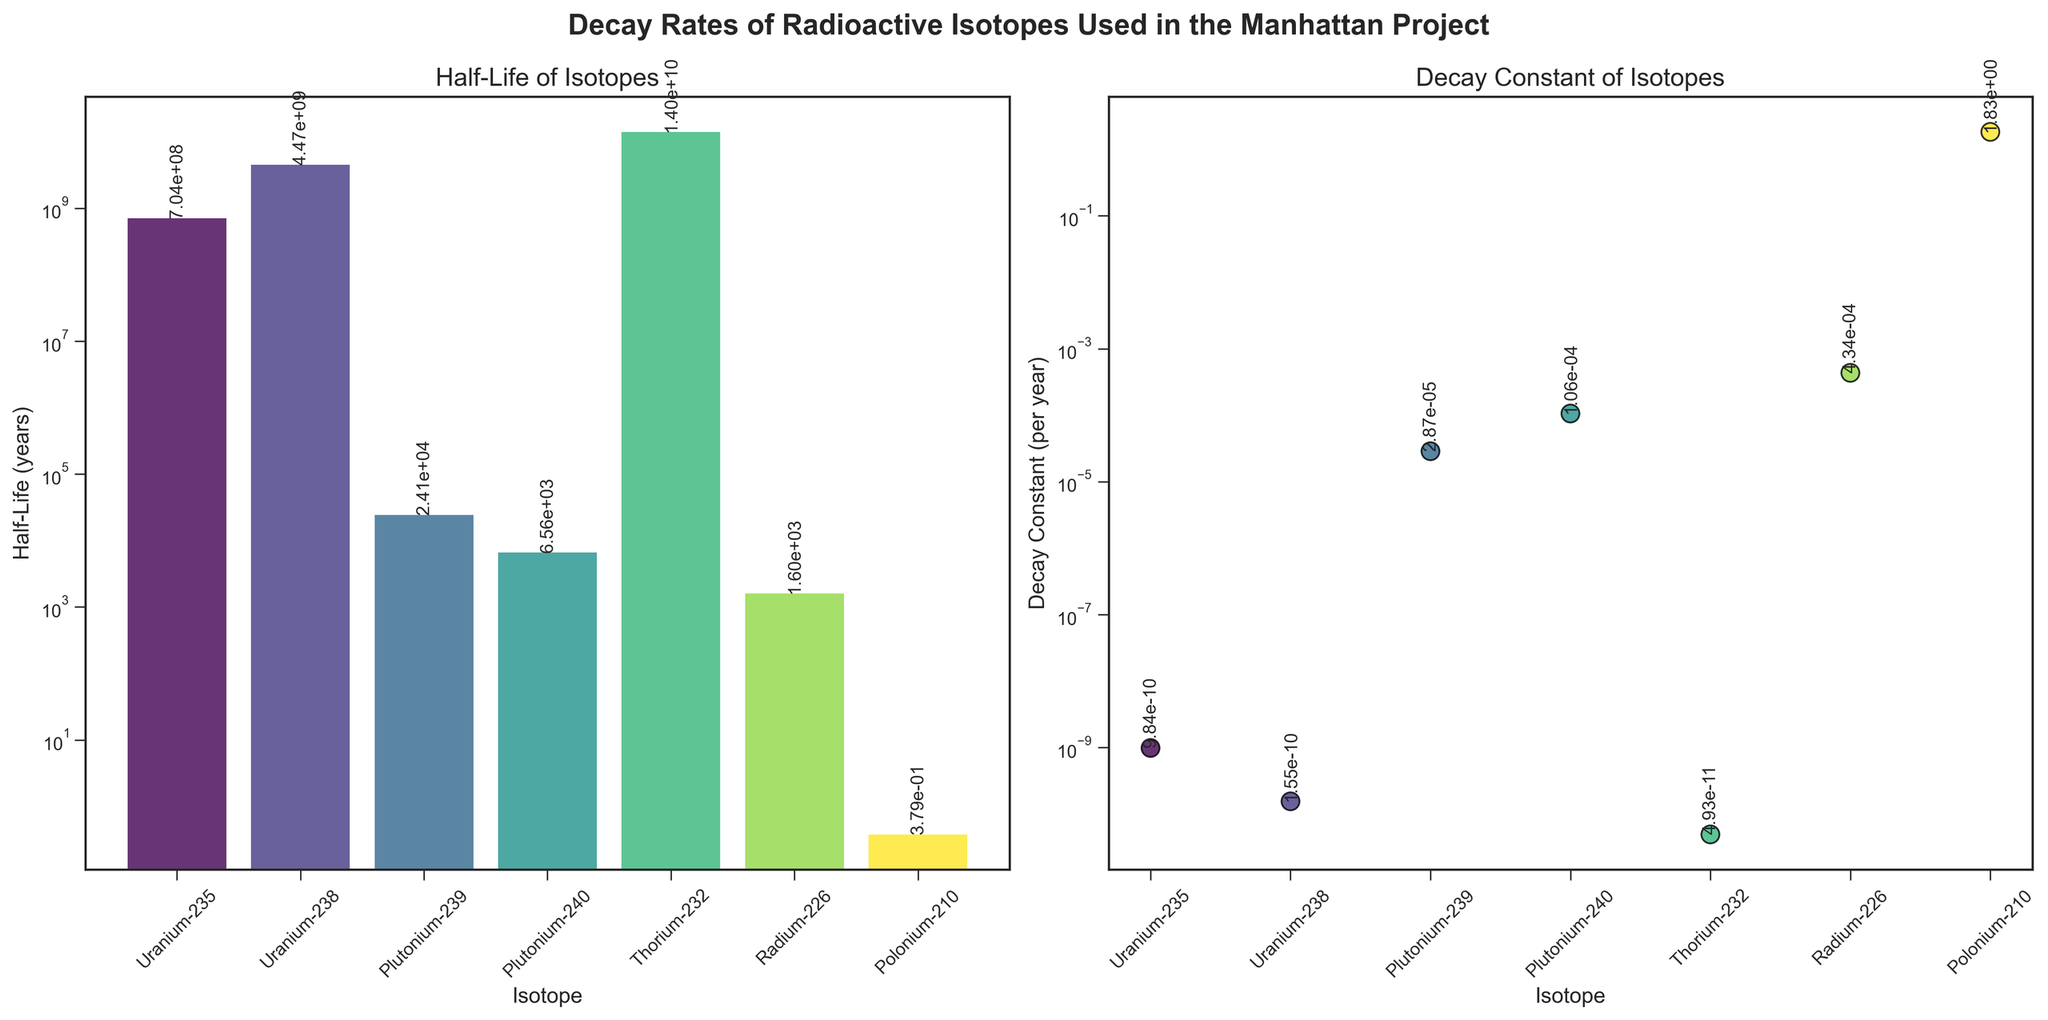What is the half-life of Uranium-235? The half-life can be directly read from the bar height in the subplot for Half-Life of Isotopes. Uranium-235's bar reaches up to approximately 7.04e8 years as labeled.
Answer: 7.04e8 years Which isotope has the highest decay constant? By examining the scatter plot in the subplot for Decay Constant of Isotopes, we see that Polonium-210 has the highest point, with a labeled decay constant of 1.83 per year.
Answer: Polonium-210 How does the half-life of Uranium-238 compare to that of Thorium-232? Find the bars for Uranium-238 and Thorium-232 in the Half-Life subplot. The half-life of Uranium-238 (4.468e9 years) is less than that of Thorium-232 (1.405e10 years).
Answer: Less than How many isotopes have a half-life greater than 1 billion years? Look at the bar heights in the Half-Life subplot. There are three bars above the 1 billion years mark: Uranium-235, Uranium-238, and Thorium-232.
Answer: Three What is the half-life difference between Plutonium-239 and Plutonium-240? Subtract the half-life of Plutonium-240 from that of Plutonium-239 by referring to the labeled values in the Half-Life subplot (2.41e4 years - 6.561e3 years).
Answer: 1.7539e4 years Which isotope has the smallest decay constant? Identify the lowest point on the scatter plot in the Decay Constant subplot. Thorium-232 is the lowest with a decay constant of 4.93e-11 per year.
Answer: Thorium-232 What trend is observed between half-life and decay constant of the isotopes? Generally, isotopes with longer half-lives tend to have smaller decay constants, as observed from the Half-Life and Decay Constant subplots; particularly, isotopes with half-lives on the higher end have decay constants on the lower end and vice versa.
Answer: Inversely related Estimate the difference in decay constants between Radium-226 and Polonium-210. Refer to the scatter plot in the Decay Constant of Isotopes subplot. Subtract the decay constant of Radium-226 from that of Polonium-210 (1.83 - 4.34e-4).
Answer: Approximately 1.83 per year 